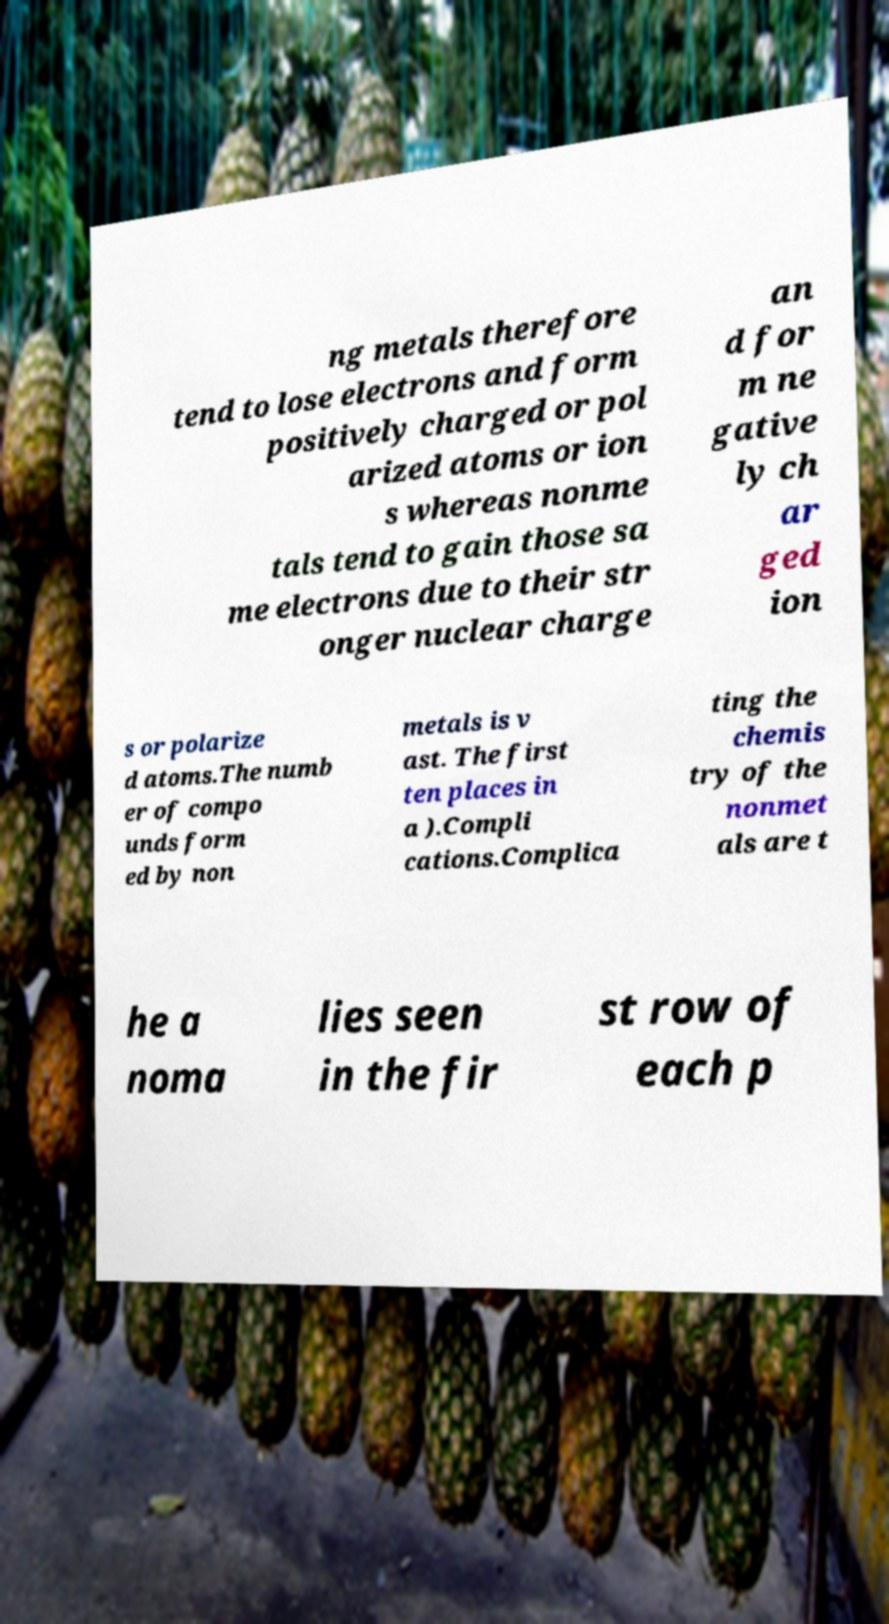Can you accurately transcribe the text from the provided image for me? ng metals therefore tend to lose electrons and form positively charged or pol arized atoms or ion s whereas nonme tals tend to gain those sa me electrons due to their str onger nuclear charge an d for m ne gative ly ch ar ged ion s or polarize d atoms.The numb er of compo unds form ed by non metals is v ast. The first ten places in a ).Compli cations.Complica ting the chemis try of the nonmet als are t he a noma lies seen in the fir st row of each p 